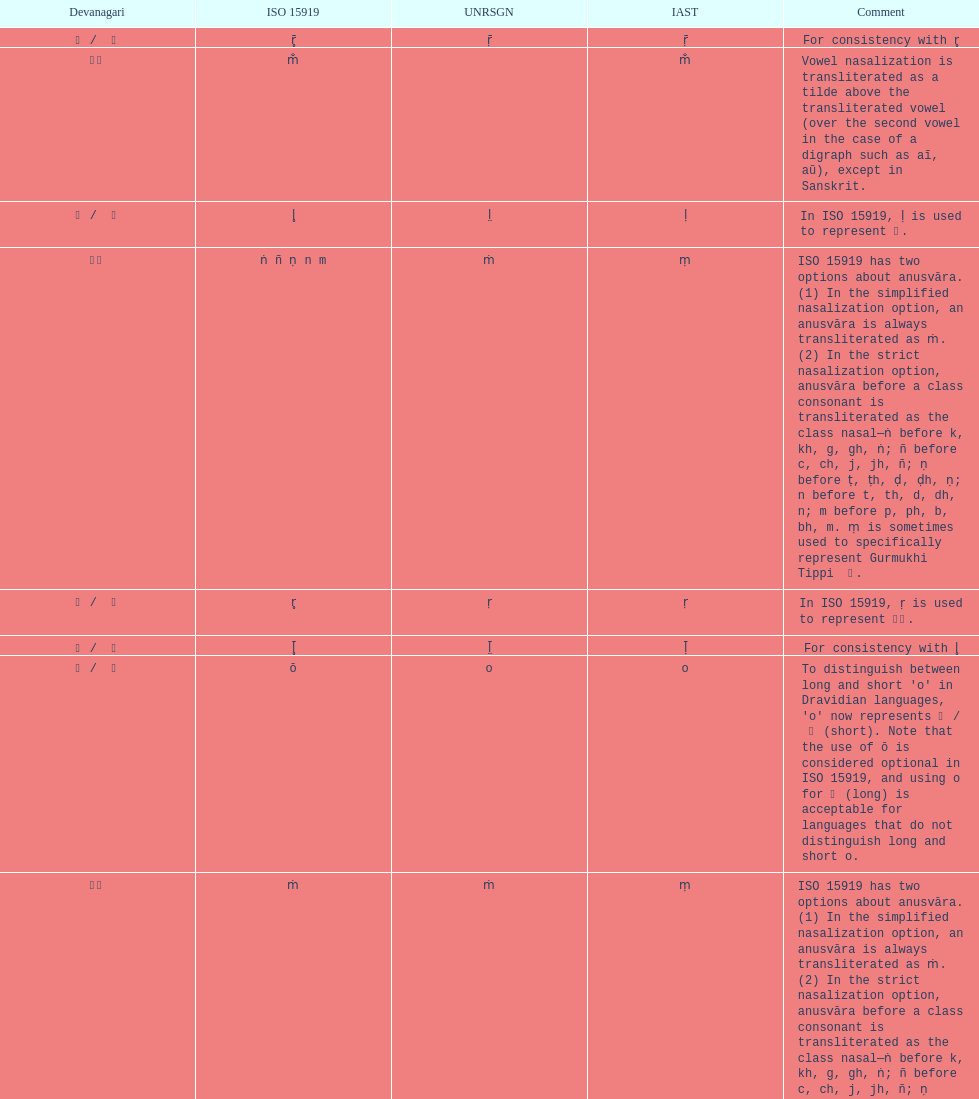What iast is listed before the o? E. 